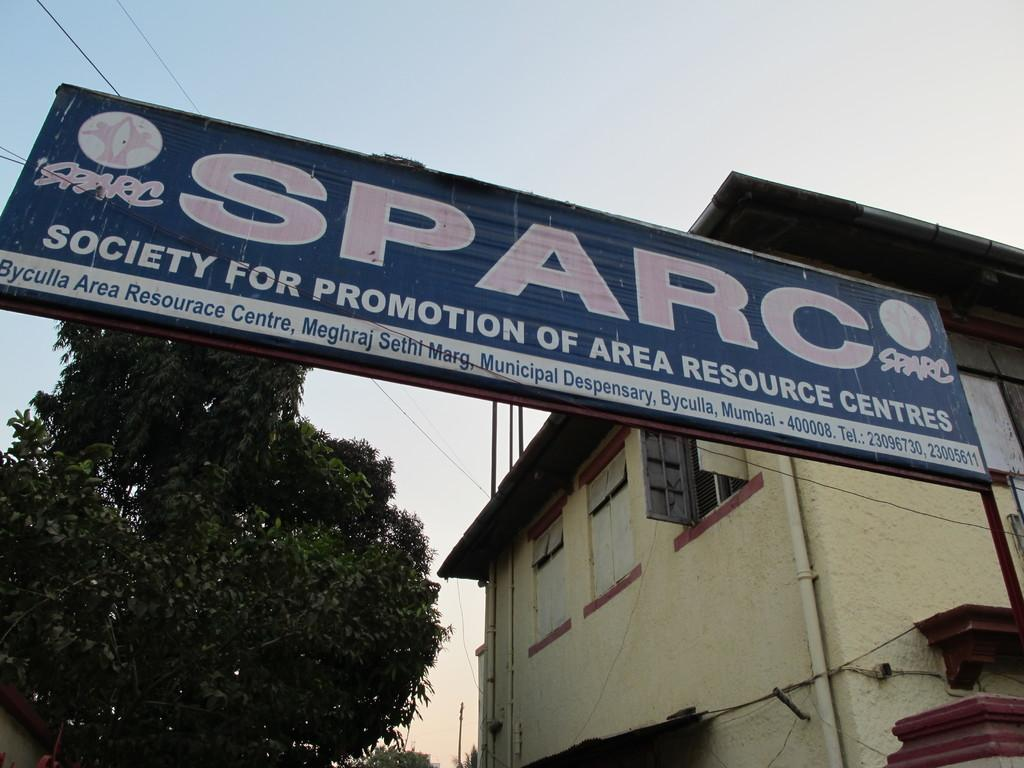What is on the board that is visible in the image? There is a board with text in the image. What can be seen in the background of the image? There are buildings, wires, trees, and the sky visible in the background of the image. How many pies are being served on the spade in the image? There are no pies or spades present in the image. What type of alarm is going off in the image? There is no alarm present in the image. 